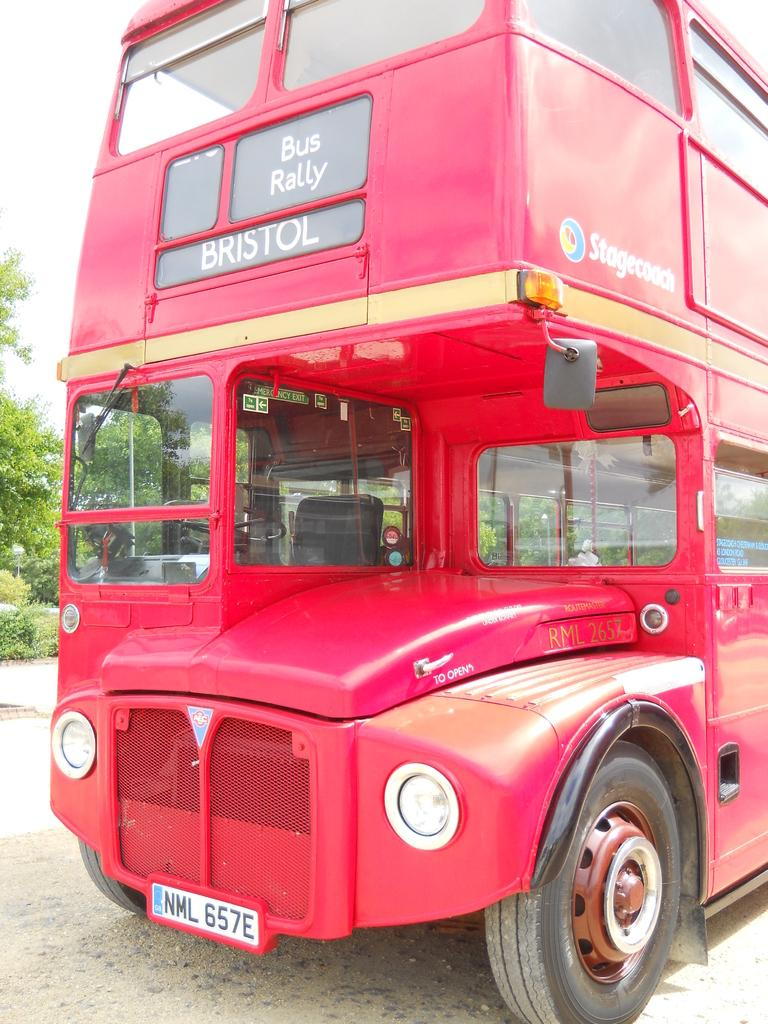What type of vehicle is in the image? There is a Double Decker bus in the image. Where is the bus located? The bus is on the road. What can be seen in the image besides the bus? There are trees visible in the image. What is visible in the background of the image? The sky is visible in the background of the image. What type of joke is being told by the giraffe in the image? There is no giraffe present in the image, so no joke can be observed. 